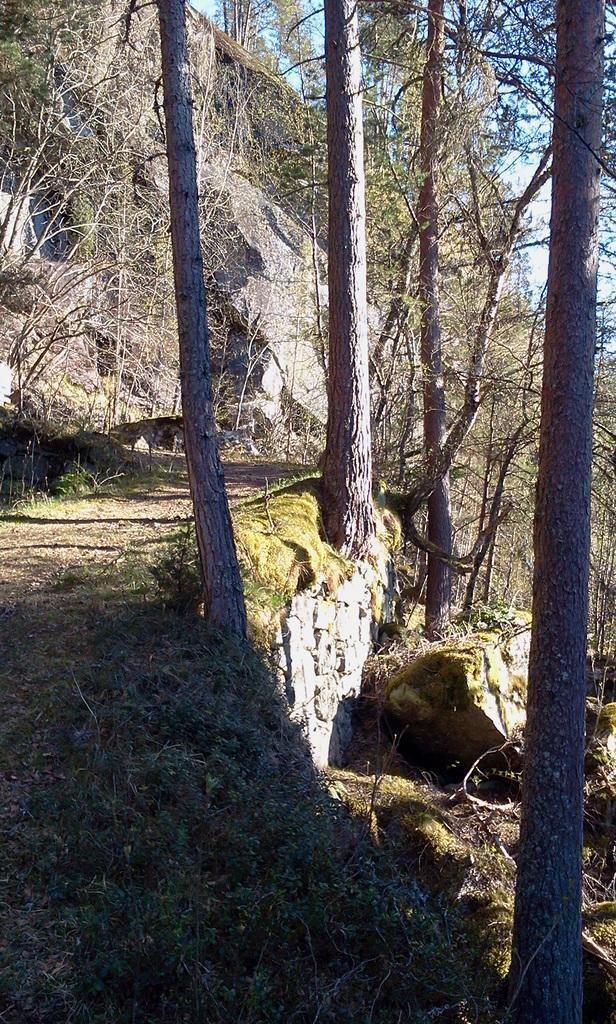How would you summarize this image in a sentence or two? In this image we can see the trunk of trees on the right side. Here we can see the walkway on the left side. In the background, we can see the rock and trees. 